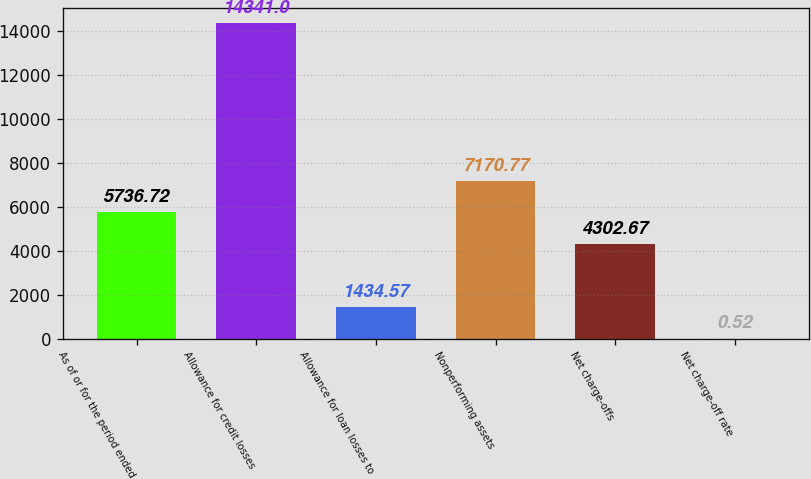<chart> <loc_0><loc_0><loc_500><loc_500><bar_chart><fcel>As of or for the period ended<fcel>Allowance for credit losses<fcel>Allowance for loan losses to<fcel>Nonperforming assets<fcel>Net charge-offs<fcel>Net charge-off rate<nl><fcel>5736.72<fcel>14341<fcel>1434.57<fcel>7170.77<fcel>4302.67<fcel>0.52<nl></chart> 